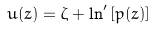Convert formula to latex. <formula><loc_0><loc_0><loc_500><loc_500>u ( z ) = \zeta + \ln ^ { \prime } \left [ p ( z ) \right ]</formula> 